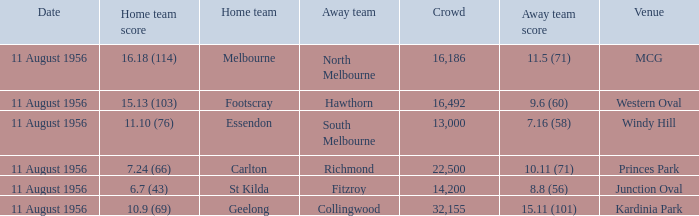What home team played at western oval? Footscray. 